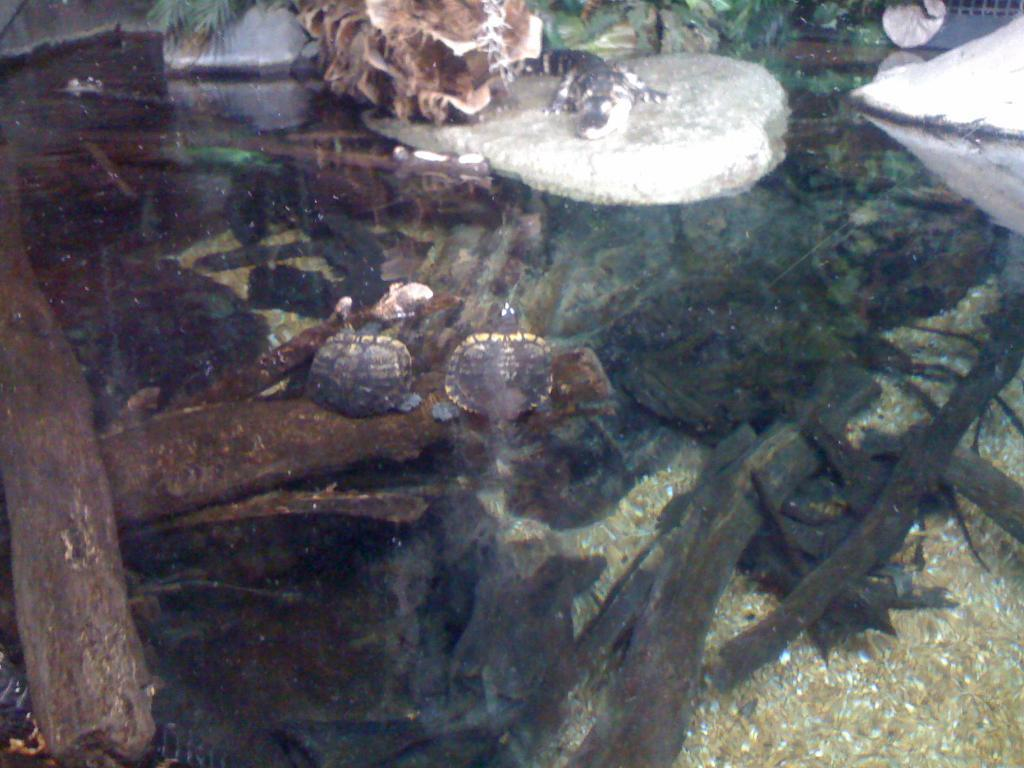What objects are present in the image that resemble long, thin pieces of wood? There are sticks in the image. What color are the objects that appear to be white in the image? There are white things in the image, but their color cannot be determined without more information. What color are the objects that appear to be brown in the image? There are brown things in the image. What type of vegetation is visible at the top of the image? Green leaves are visible at the top of the image. What is the self's desire in the image? There is no self or desire present in the image; it only contains sticks, white things, brown things, and green leaves. 